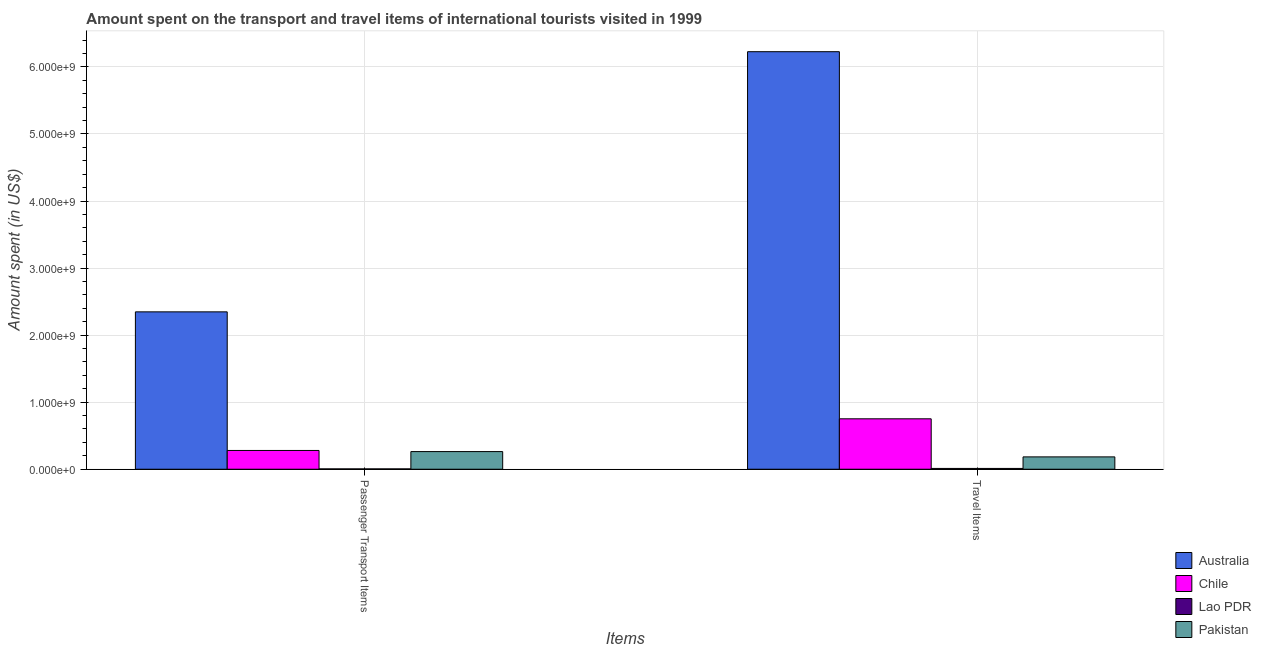Are the number of bars per tick equal to the number of legend labels?
Provide a succinct answer. Yes. How many bars are there on the 2nd tick from the left?
Make the answer very short. 4. What is the label of the 2nd group of bars from the left?
Your response must be concise. Travel Items. What is the amount spent in travel items in Lao PDR?
Ensure brevity in your answer.  1.20e+07. Across all countries, what is the maximum amount spent in travel items?
Give a very brief answer. 6.23e+09. Across all countries, what is the minimum amount spent in travel items?
Your answer should be very brief. 1.20e+07. In which country was the amount spent on passenger transport items minimum?
Ensure brevity in your answer.  Lao PDR. What is the total amount spent on passenger transport items in the graph?
Provide a short and direct response. 2.90e+09. What is the difference between the amount spent in travel items in Pakistan and that in Australia?
Your answer should be compact. -6.04e+09. What is the difference between the amount spent on passenger transport items in Australia and the amount spent in travel items in Lao PDR?
Your answer should be compact. 2.34e+09. What is the average amount spent in travel items per country?
Make the answer very short. 1.79e+09. What is the difference between the amount spent in travel items and amount spent on passenger transport items in Australia?
Keep it short and to the point. 3.88e+09. What is the ratio of the amount spent in travel items in Chile to that in Lao PDR?
Offer a terse response. 62.67. In how many countries, is the amount spent on passenger transport items greater than the average amount spent on passenger transport items taken over all countries?
Give a very brief answer. 1. What does the 3rd bar from the left in Passenger Transport Items represents?
Ensure brevity in your answer.  Lao PDR. What does the 1st bar from the right in Passenger Transport Items represents?
Offer a terse response. Pakistan. How many bars are there?
Ensure brevity in your answer.  8. Are all the bars in the graph horizontal?
Provide a short and direct response. No. How many countries are there in the graph?
Give a very brief answer. 4. Are the values on the major ticks of Y-axis written in scientific E-notation?
Keep it short and to the point. Yes. Where does the legend appear in the graph?
Provide a succinct answer. Bottom right. How many legend labels are there?
Provide a succinct answer. 4. What is the title of the graph?
Keep it short and to the point. Amount spent on the transport and travel items of international tourists visited in 1999. Does "Turks and Caicos Islands" appear as one of the legend labels in the graph?
Your answer should be compact. No. What is the label or title of the X-axis?
Provide a short and direct response. Items. What is the label or title of the Y-axis?
Your response must be concise. Amount spent (in US$). What is the Amount spent (in US$) of Australia in Passenger Transport Items?
Provide a short and direct response. 2.35e+09. What is the Amount spent (in US$) of Chile in Passenger Transport Items?
Provide a short and direct response. 2.80e+08. What is the Amount spent (in US$) of Pakistan in Passenger Transport Items?
Your response must be concise. 2.63e+08. What is the Amount spent (in US$) in Australia in Travel Items?
Your answer should be compact. 6.23e+09. What is the Amount spent (in US$) in Chile in Travel Items?
Offer a very short reply. 7.52e+08. What is the Amount spent (in US$) in Lao PDR in Travel Items?
Offer a very short reply. 1.20e+07. What is the Amount spent (in US$) of Pakistan in Travel Items?
Ensure brevity in your answer.  1.84e+08. Across all Items, what is the maximum Amount spent (in US$) in Australia?
Keep it short and to the point. 6.23e+09. Across all Items, what is the maximum Amount spent (in US$) in Chile?
Make the answer very short. 7.52e+08. Across all Items, what is the maximum Amount spent (in US$) of Lao PDR?
Your response must be concise. 1.20e+07. Across all Items, what is the maximum Amount spent (in US$) in Pakistan?
Offer a terse response. 2.63e+08. Across all Items, what is the minimum Amount spent (in US$) of Australia?
Provide a succinct answer. 2.35e+09. Across all Items, what is the minimum Amount spent (in US$) of Chile?
Ensure brevity in your answer.  2.80e+08. Across all Items, what is the minimum Amount spent (in US$) of Lao PDR?
Offer a very short reply. 5.00e+06. Across all Items, what is the minimum Amount spent (in US$) in Pakistan?
Offer a terse response. 1.84e+08. What is the total Amount spent (in US$) of Australia in the graph?
Provide a short and direct response. 8.57e+09. What is the total Amount spent (in US$) of Chile in the graph?
Your response must be concise. 1.03e+09. What is the total Amount spent (in US$) in Lao PDR in the graph?
Provide a short and direct response. 1.70e+07. What is the total Amount spent (in US$) in Pakistan in the graph?
Ensure brevity in your answer.  4.47e+08. What is the difference between the Amount spent (in US$) of Australia in Passenger Transport Items and that in Travel Items?
Your answer should be very brief. -3.88e+09. What is the difference between the Amount spent (in US$) in Chile in Passenger Transport Items and that in Travel Items?
Offer a very short reply. -4.72e+08. What is the difference between the Amount spent (in US$) in Lao PDR in Passenger Transport Items and that in Travel Items?
Ensure brevity in your answer.  -7.00e+06. What is the difference between the Amount spent (in US$) in Pakistan in Passenger Transport Items and that in Travel Items?
Ensure brevity in your answer.  7.90e+07. What is the difference between the Amount spent (in US$) of Australia in Passenger Transport Items and the Amount spent (in US$) of Chile in Travel Items?
Your response must be concise. 1.60e+09. What is the difference between the Amount spent (in US$) in Australia in Passenger Transport Items and the Amount spent (in US$) in Lao PDR in Travel Items?
Provide a succinct answer. 2.34e+09. What is the difference between the Amount spent (in US$) in Australia in Passenger Transport Items and the Amount spent (in US$) in Pakistan in Travel Items?
Provide a short and direct response. 2.16e+09. What is the difference between the Amount spent (in US$) of Chile in Passenger Transport Items and the Amount spent (in US$) of Lao PDR in Travel Items?
Offer a very short reply. 2.68e+08. What is the difference between the Amount spent (in US$) of Chile in Passenger Transport Items and the Amount spent (in US$) of Pakistan in Travel Items?
Your response must be concise. 9.60e+07. What is the difference between the Amount spent (in US$) of Lao PDR in Passenger Transport Items and the Amount spent (in US$) of Pakistan in Travel Items?
Make the answer very short. -1.79e+08. What is the average Amount spent (in US$) in Australia per Items?
Ensure brevity in your answer.  4.29e+09. What is the average Amount spent (in US$) in Chile per Items?
Keep it short and to the point. 5.16e+08. What is the average Amount spent (in US$) of Lao PDR per Items?
Ensure brevity in your answer.  8.50e+06. What is the average Amount spent (in US$) of Pakistan per Items?
Give a very brief answer. 2.24e+08. What is the difference between the Amount spent (in US$) of Australia and Amount spent (in US$) of Chile in Passenger Transport Items?
Your response must be concise. 2.07e+09. What is the difference between the Amount spent (in US$) of Australia and Amount spent (in US$) of Lao PDR in Passenger Transport Items?
Your answer should be compact. 2.34e+09. What is the difference between the Amount spent (in US$) in Australia and Amount spent (in US$) in Pakistan in Passenger Transport Items?
Offer a terse response. 2.08e+09. What is the difference between the Amount spent (in US$) in Chile and Amount spent (in US$) in Lao PDR in Passenger Transport Items?
Make the answer very short. 2.75e+08. What is the difference between the Amount spent (in US$) in Chile and Amount spent (in US$) in Pakistan in Passenger Transport Items?
Your answer should be very brief. 1.70e+07. What is the difference between the Amount spent (in US$) in Lao PDR and Amount spent (in US$) in Pakistan in Passenger Transport Items?
Your response must be concise. -2.58e+08. What is the difference between the Amount spent (in US$) of Australia and Amount spent (in US$) of Chile in Travel Items?
Provide a succinct answer. 5.48e+09. What is the difference between the Amount spent (in US$) of Australia and Amount spent (in US$) of Lao PDR in Travel Items?
Offer a terse response. 6.22e+09. What is the difference between the Amount spent (in US$) in Australia and Amount spent (in US$) in Pakistan in Travel Items?
Make the answer very short. 6.04e+09. What is the difference between the Amount spent (in US$) of Chile and Amount spent (in US$) of Lao PDR in Travel Items?
Offer a terse response. 7.40e+08. What is the difference between the Amount spent (in US$) of Chile and Amount spent (in US$) of Pakistan in Travel Items?
Offer a very short reply. 5.68e+08. What is the difference between the Amount spent (in US$) in Lao PDR and Amount spent (in US$) in Pakistan in Travel Items?
Offer a very short reply. -1.72e+08. What is the ratio of the Amount spent (in US$) of Australia in Passenger Transport Items to that in Travel Items?
Your answer should be compact. 0.38. What is the ratio of the Amount spent (in US$) in Chile in Passenger Transport Items to that in Travel Items?
Make the answer very short. 0.37. What is the ratio of the Amount spent (in US$) of Lao PDR in Passenger Transport Items to that in Travel Items?
Provide a short and direct response. 0.42. What is the ratio of the Amount spent (in US$) of Pakistan in Passenger Transport Items to that in Travel Items?
Keep it short and to the point. 1.43. What is the difference between the highest and the second highest Amount spent (in US$) in Australia?
Your response must be concise. 3.88e+09. What is the difference between the highest and the second highest Amount spent (in US$) of Chile?
Offer a terse response. 4.72e+08. What is the difference between the highest and the second highest Amount spent (in US$) of Lao PDR?
Provide a short and direct response. 7.00e+06. What is the difference between the highest and the second highest Amount spent (in US$) of Pakistan?
Your answer should be compact. 7.90e+07. What is the difference between the highest and the lowest Amount spent (in US$) in Australia?
Your answer should be compact. 3.88e+09. What is the difference between the highest and the lowest Amount spent (in US$) in Chile?
Offer a very short reply. 4.72e+08. What is the difference between the highest and the lowest Amount spent (in US$) in Pakistan?
Give a very brief answer. 7.90e+07. 